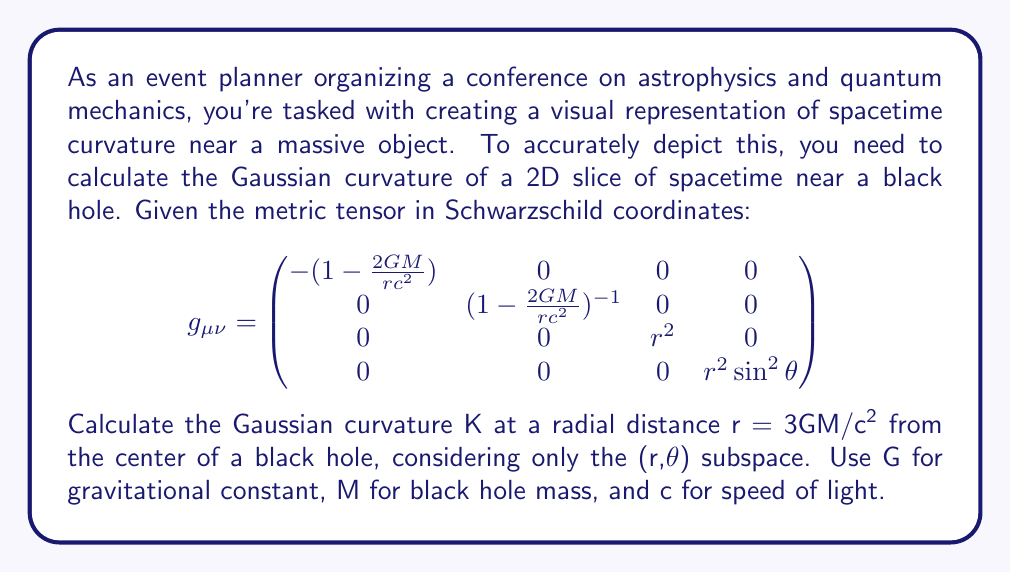Can you solve this math problem? To calculate the Gaussian curvature K of the (r,θ) subspace, we'll follow these steps:

1) First, we extract the relevant components of the metric tensor for the (r,θ) subspace:

   $$g_{rr} = (1-\frac{2GM}{rc^2})^{-1}$$
   $$g_{\theta\theta} = r^2$$

2) The Gaussian curvature K for a 2D surface with metric ds^2 = E dr^2 + G dθ^2 is given by:

   $$K = -\frac{1}{2\sqrt{EG}} \left[\frac{\partial}{\partial r}\left(\frac{\sqrt{G}}{\sqrt{E}}\frac{\partial \sqrt{E}}{\partial r}\right) + \frac{\partial}{\partial \theta}\left(\frac{\sqrt{E}}{\sqrt{G}}\frac{\partial \sqrt{G}}{\partial \theta}\right)\right]$$

3) In our case, E = g_rr and G = g_θθ. Let's calculate the derivatives:

   $$\frac{\partial \sqrt{E}}{\partial r} = -\frac{GM}{r^2c^2}(1-\frac{2GM}{rc^2})^{-3/2}$$
   $$\frac{\partial \sqrt{G}}{\partial r} = 1$$
   $$\frac{\partial \sqrt{G}}{\partial \theta} = 0$$

4) Substituting these into the curvature formula:

   $$K = -\frac{1}{2r\sqrt{1-\frac{2GM}{rc^2}}} \left[\frac{\partial}{\partial r}\left(r\sqrt{1-\frac{2GM}{rc^2}}\cdot-\frac{GM}{r^2c^2}(1-\frac{2GM}{rc^2})^{-3/2}\right) + 0\right]$$

5) Simplifying and evaluating the derivative:

   $$K = \frac{GM}{r^3c^2}$$

6) Now, we substitute r = 3GM/c^2:

   $$K = \frac{GM}{(\frac{3GM}{c^2})^3c^2} = \frac{c^6}{27G^2M^2}$$

This is the Gaussian curvature at r = 3GM/c^2 in the (r,θ) subspace of the Schwarzschild metric.
Answer: $$K = \frac{c^6}{27G^2M^2}$$ 